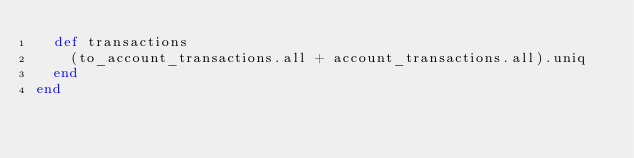<code> <loc_0><loc_0><loc_500><loc_500><_Ruby_>  def transactions
    (to_account_transactions.all + account_transactions.all).uniq
  end
end
</code> 